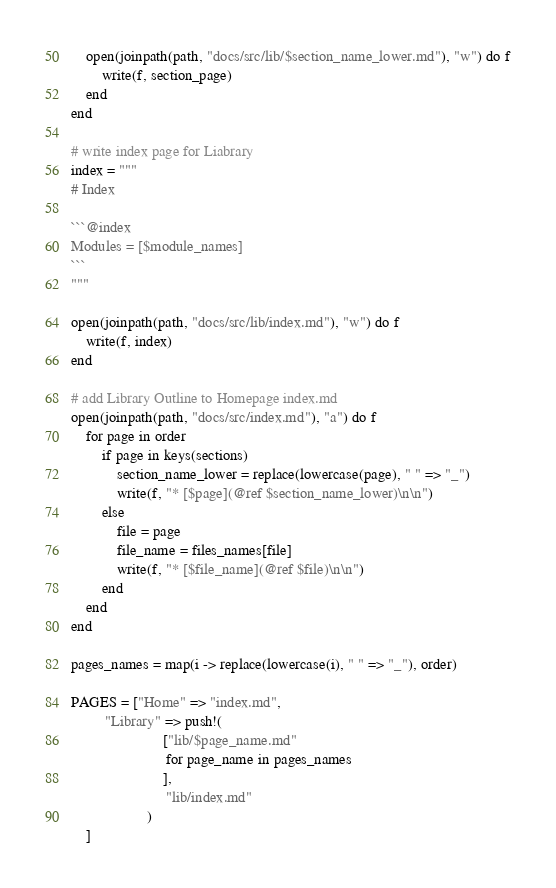<code> <loc_0><loc_0><loc_500><loc_500><_Julia_>    open(joinpath(path, "docs/src/lib/$section_name_lower.md"), "w") do f
        write(f, section_page)
    end
end

# write index page for Liabrary
index = """
# Index

```@index
Modules = [$module_names]
```
"""

open(joinpath(path, "docs/src/lib/index.md"), "w") do f
    write(f, index)
end

# add Library Outline to Homepage index.md
open(joinpath(path, "docs/src/index.md"), "a") do f
    for page in order
        if page in keys(sections)
            section_name_lower = replace(lowercase(page), " " => "_")
            write(f, "* [$page](@ref $section_name_lower)\n\n")
        else
            file = page
            file_name = files_names[file]
            write(f, "* [$file_name](@ref $file)\n\n")
        end
    end
end

pages_names = map(i -> replace(lowercase(i), " " => "_"), order)

PAGES = ["Home" => "index.md",
         "Library" => push!(
                        ["lib/$page_name.md" 
                         for page_name in pages_names
                        ],
                         "lib/index.md"
                    )
    ]
</code> 